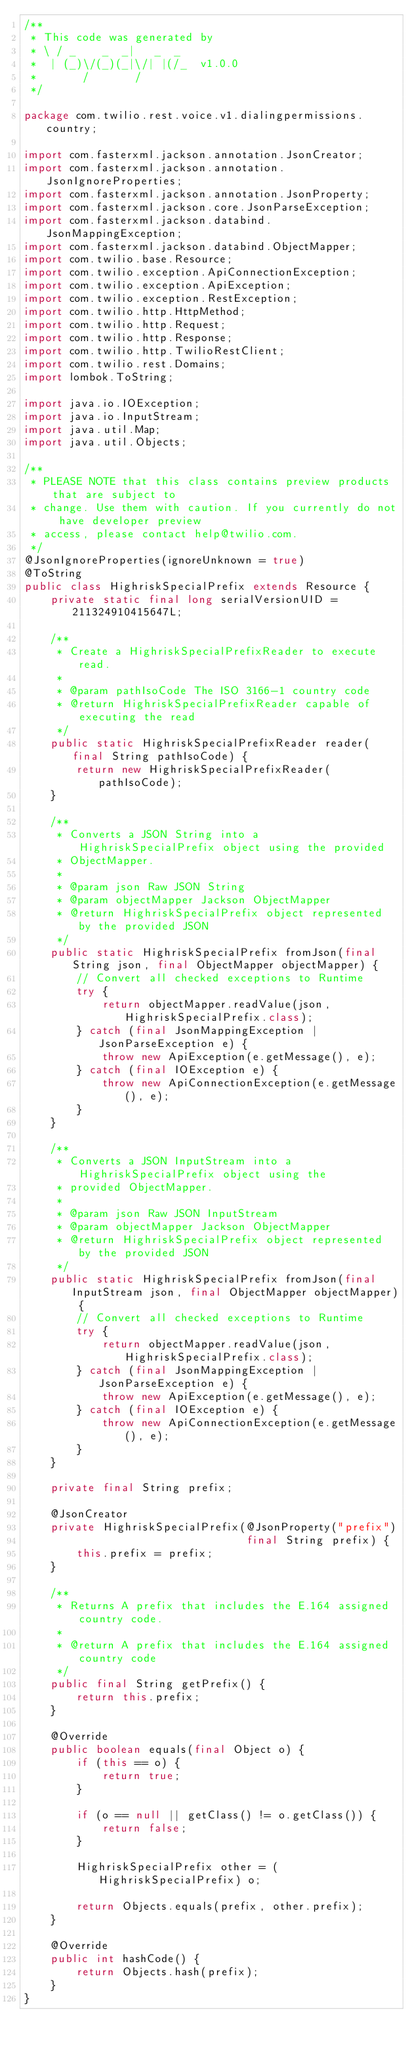Convert code to text. <code><loc_0><loc_0><loc_500><loc_500><_Java_>/**
 * This code was generated by
 * \ / _    _  _|   _  _
 *  | (_)\/(_)(_|\/| |(/_  v1.0.0
 *       /       /
 */

package com.twilio.rest.voice.v1.dialingpermissions.country;

import com.fasterxml.jackson.annotation.JsonCreator;
import com.fasterxml.jackson.annotation.JsonIgnoreProperties;
import com.fasterxml.jackson.annotation.JsonProperty;
import com.fasterxml.jackson.core.JsonParseException;
import com.fasterxml.jackson.databind.JsonMappingException;
import com.fasterxml.jackson.databind.ObjectMapper;
import com.twilio.base.Resource;
import com.twilio.exception.ApiConnectionException;
import com.twilio.exception.ApiException;
import com.twilio.exception.RestException;
import com.twilio.http.HttpMethod;
import com.twilio.http.Request;
import com.twilio.http.Response;
import com.twilio.http.TwilioRestClient;
import com.twilio.rest.Domains;
import lombok.ToString;

import java.io.IOException;
import java.io.InputStream;
import java.util.Map;
import java.util.Objects;

/**
 * PLEASE NOTE that this class contains preview products that are subject to
 * change. Use them with caution. If you currently do not have developer preview
 * access, please contact help@twilio.com.
 */
@JsonIgnoreProperties(ignoreUnknown = true)
@ToString
public class HighriskSpecialPrefix extends Resource {
    private static final long serialVersionUID = 211324910415647L;

    /**
     * Create a HighriskSpecialPrefixReader to execute read.
     *
     * @param pathIsoCode The ISO 3166-1 country code
     * @return HighriskSpecialPrefixReader capable of executing the read
     */
    public static HighriskSpecialPrefixReader reader(final String pathIsoCode) {
        return new HighriskSpecialPrefixReader(pathIsoCode);
    }

    /**
     * Converts a JSON String into a HighriskSpecialPrefix object using the provided
     * ObjectMapper.
     *
     * @param json Raw JSON String
     * @param objectMapper Jackson ObjectMapper
     * @return HighriskSpecialPrefix object represented by the provided JSON
     */
    public static HighriskSpecialPrefix fromJson(final String json, final ObjectMapper objectMapper) {
        // Convert all checked exceptions to Runtime
        try {
            return objectMapper.readValue(json, HighriskSpecialPrefix.class);
        } catch (final JsonMappingException | JsonParseException e) {
            throw new ApiException(e.getMessage(), e);
        } catch (final IOException e) {
            throw new ApiConnectionException(e.getMessage(), e);
        }
    }

    /**
     * Converts a JSON InputStream into a HighriskSpecialPrefix object using the
     * provided ObjectMapper.
     *
     * @param json Raw JSON InputStream
     * @param objectMapper Jackson ObjectMapper
     * @return HighriskSpecialPrefix object represented by the provided JSON
     */
    public static HighriskSpecialPrefix fromJson(final InputStream json, final ObjectMapper objectMapper) {
        // Convert all checked exceptions to Runtime
        try {
            return objectMapper.readValue(json, HighriskSpecialPrefix.class);
        } catch (final JsonMappingException | JsonParseException e) {
            throw new ApiException(e.getMessage(), e);
        } catch (final IOException e) {
            throw new ApiConnectionException(e.getMessage(), e);
        }
    }

    private final String prefix;

    @JsonCreator
    private HighriskSpecialPrefix(@JsonProperty("prefix")
                                  final String prefix) {
        this.prefix = prefix;
    }

    /**
     * Returns A prefix that includes the E.164 assigned country code.
     *
     * @return A prefix that includes the E.164 assigned country code
     */
    public final String getPrefix() {
        return this.prefix;
    }

    @Override
    public boolean equals(final Object o) {
        if (this == o) {
            return true;
        }

        if (o == null || getClass() != o.getClass()) {
            return false;
        }

        HighriskSpecialPrefix other = (HighriskSpecialPrefix) o;

        return Objects.equals(prefix, other.prefix);
    }

    @Override
    public int hashCode() {
        return Objects.hash(prefix);
    }
}</code> 